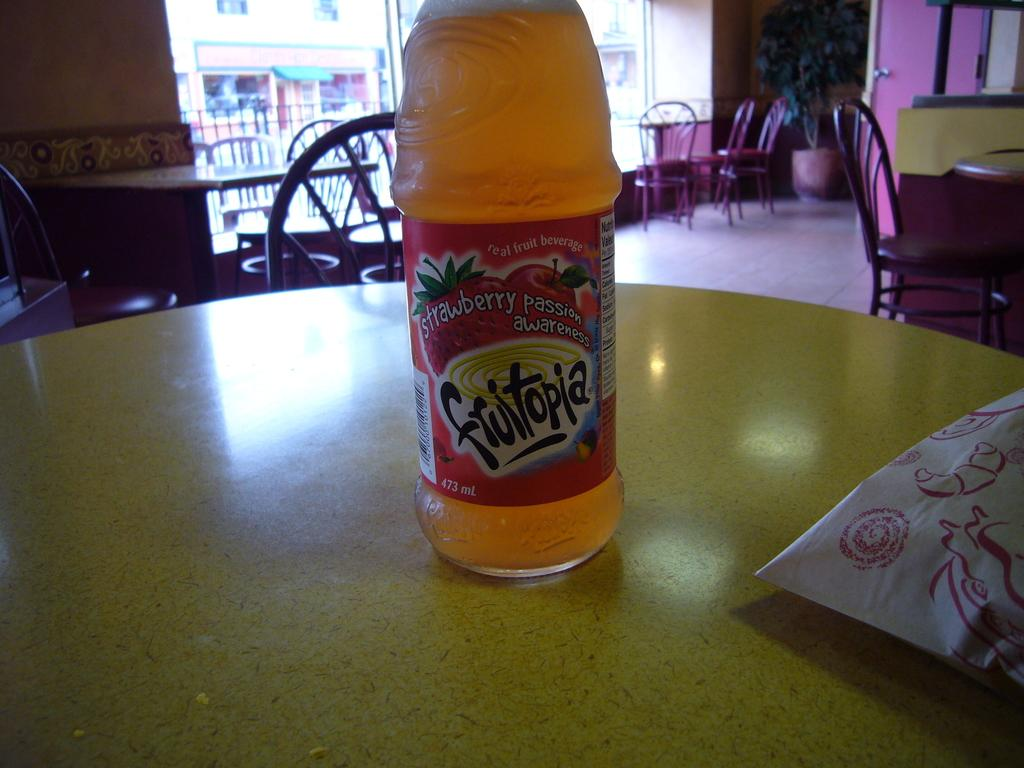What object is placed on the table in the image? There is a bottle on the table. What type of furniture can be seen in the background? There are tables and chairs in the background. What kind of vegetation is present in the background? There is a plant in the background. What architectural feature is visible in the background? There is a glass door in the background. What can be seen through the glass door? A building is visible through the glass door. How many apples are on the table in the image? There are no apples present in the image. What type of destruction can be seen in the image? There is no destruction present in the image. 